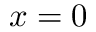Convert formula to latex. <formula><loc_0><loc_0><loc_500><loc_500>x = 0</formula> 